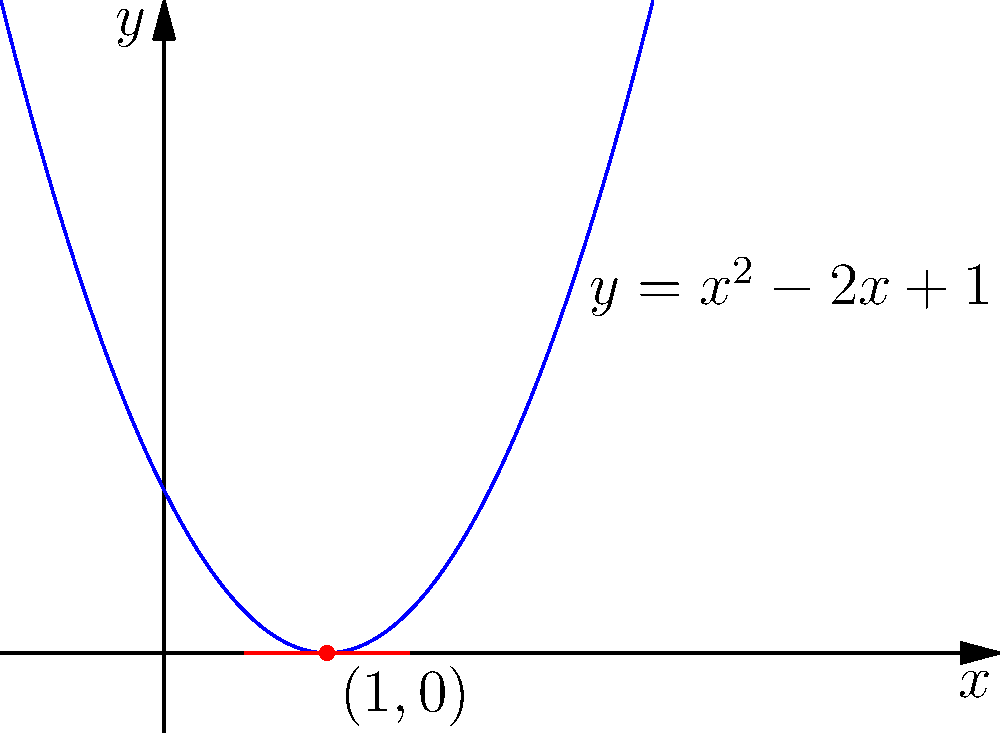As a former primary school teacher introducing calculus concepts to young STEM enthusiasts, you want to explain the slope of a tangent line. Consider the parabola $y = x^2 - 2x + 1$ shown in the graph. What is the slope of the tangent line to this parabola at the point $(1, 0)$? Let's approach this step-by-step:

1) The general formula for the slope of a tangent line to a parabola $y = ax^2 + bx + c$ at any point $x$ is given by the derivative:

   $\frac{dy}{dx} = 2ax + b$

2) In our case, $y = x^2 - 2x + 1$, so $a = 1$, $b = -2$, and $c = 1$

3) Substituting these values into the slope formula:

   $\frac{dy}{dx} = 2(1)x + (-2) = 2x - 2$

4) We want to find the slope at the point $(1, 0)$, so we substitute $x = 1$:

   Slope at $(1, 0) = 2(1) - 2 = 2 - 2 = 0$

5) We can verify this visually: the tangent line at $(1, 0)$ appears to be horizontal, which corresponds to a slope of 0.

This concept can be introduced to young STEM enthusiasts as "the steepness of the curve at a specific point," making it more relatable and easier to understand.
Answer: $0$ 